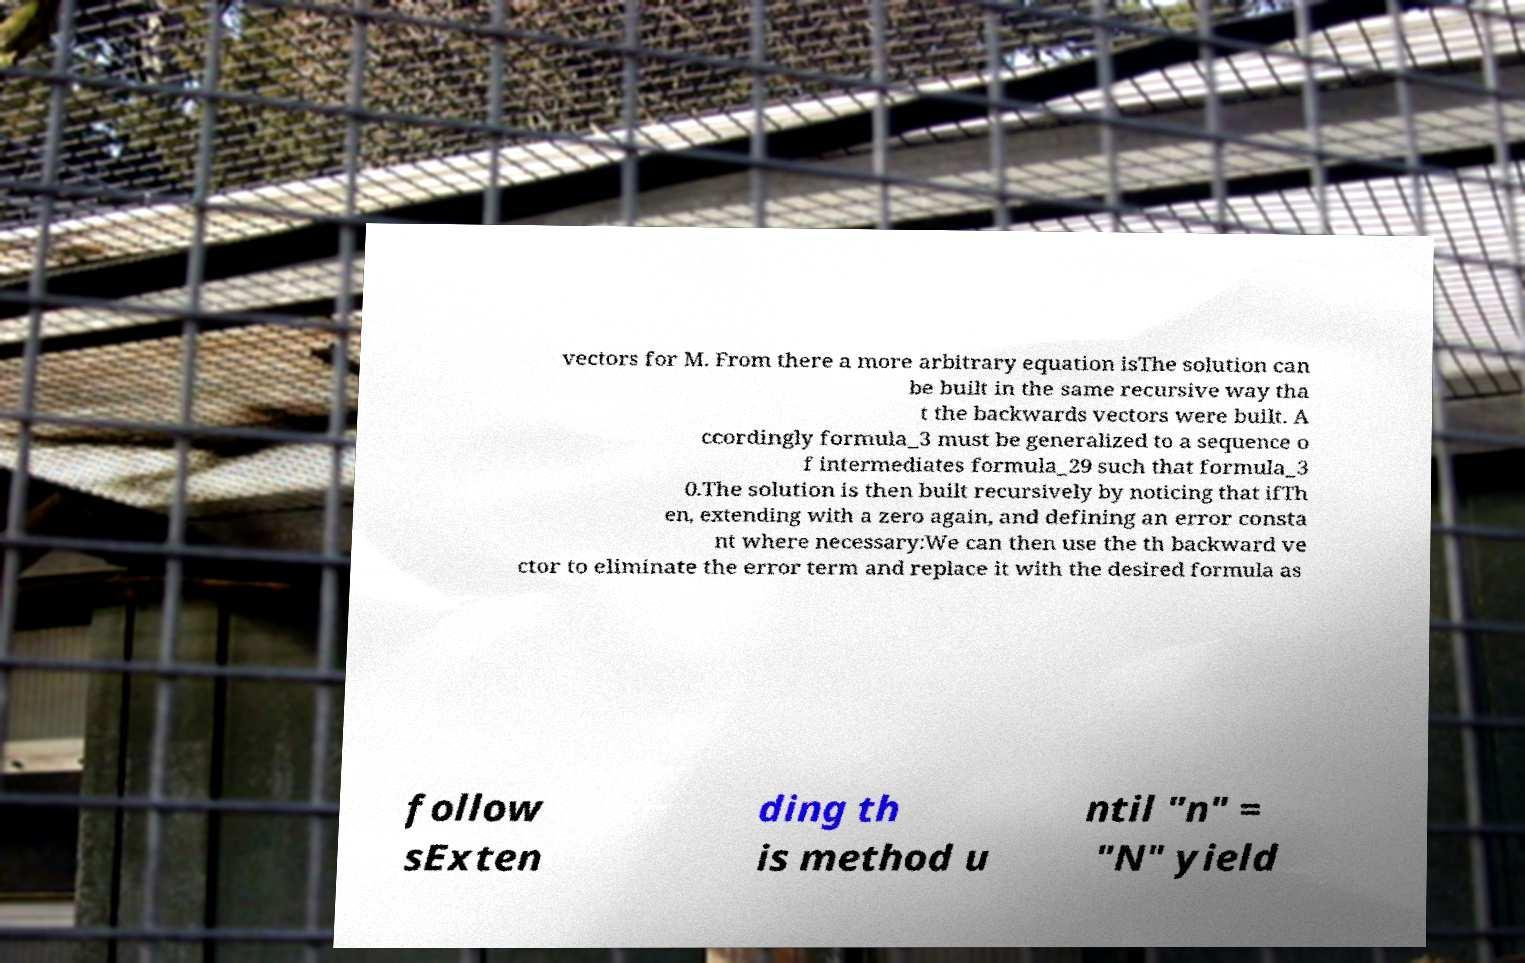Please identify and transcribe the text found in this image. vectors for M. From there a more arbitrary equation isThe solution can be built in the same recursive way tha t the backwards vectors were built. A ccordingly formula_3 must be generalized to a sequence o f intermediates formula_29 such that formula_3 0.The solution is then built recursively by noticing that ifTh en, extending with a zero again, and defining an error consta nt where necessary:We can then use the th backward ve ctor to eliminate the error term and replace it with the desired formula as follow sExten ding th is method u ntil "n" = "N" yield 